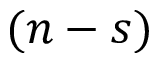<formula> <loc_0><loc_0><loc_500><loc_500>( n - s )</formula> 